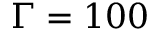<formula> <loc_0><loc_0><loc_500><loc_500>\Gamma = 1 0 0</formula> 